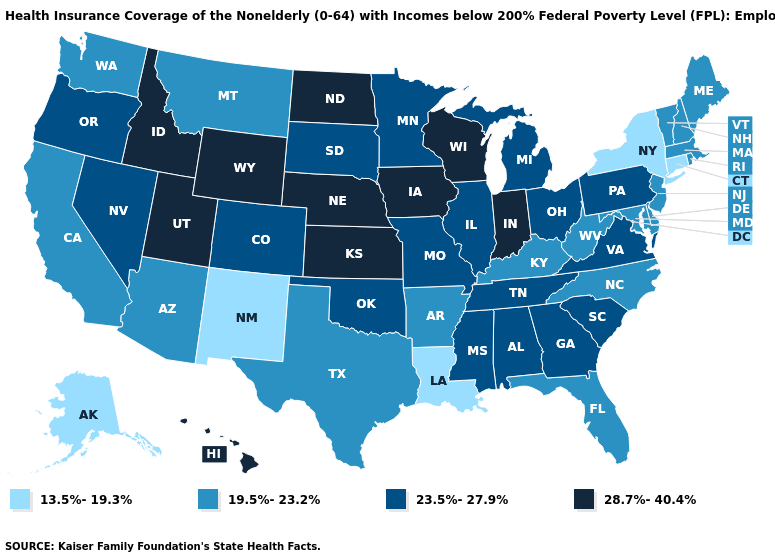What is the highest value in the USA?
Write a very short answer. 28.7%-40.4%. Does the map have missing data?
Short answer required. No. What is the value of Kentucky?
Answer briefly. 19.5%-23.2%. What is the value of Oregon?
Give a very brief answer. 23.5%-27.9%. Among the states that border Idaho , does Wyoming have the highest value?
Give a very brief answer. Yes. Among the states that border Minnesota , does Iowa have the lowest value?
Keep it brief. No. Among the states that border New Mexico , does Colorado have the lowest value?
Quick response, please. No. What is the highest value in the USA?
Write a very short answer. 28.7%-40.4%. What is the lowest value in states that border South Dakota?
Short answer required. 19.5%-23.2%. Name the states that have a value in the range 23.5%-27.9%?
Answer briefly. Alabama, Colorado, Georgia, Illinois, Michigan, Minnesota, Mississippi, Missouri, Nevada, Ohio, Oklahoma, Oregon, Pennsylvania, South Carolina, South Dakota, Tennessee, Virginia. Does the first symbol in the legend represent the smallest category?
Keep it brief. Yes. Which states hav the highest value in the Northeast?
Be succinct. Pennsylvania. Among the states that border Kansas , does Oklahoma have the highest value?
Keep it brief. No. What is the value of Michigan?
Give a very brief answer. 23.5%-27.9%. What is the value of Oregon?
Keep it brief. 23.5%-27.9%. 